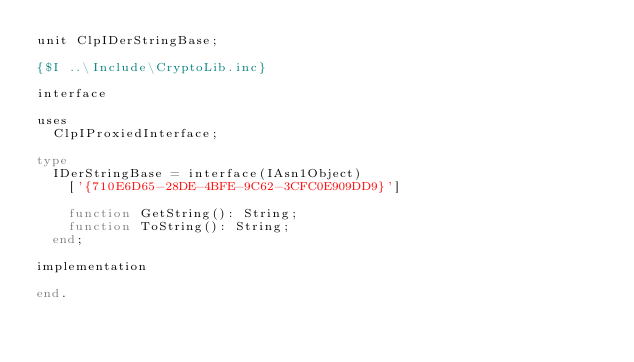Convert code to text. <code><loc_0><loc_0><loc_500><loc_500><_Pascal_>unit ClpIDerStringBase;

{$I ..\Include\CryptoLib.inc}

interface

uses
  ClpIProxiedInterface;

type
  IDerStringBase = interface(IAsn1Object)
    ['{710E6D65-28DE-4BFE-9C62-3CFC0E909DD9}']

    function GetString(): String;
    function ToString(): String;
  end;

implementation

end.
</code> 